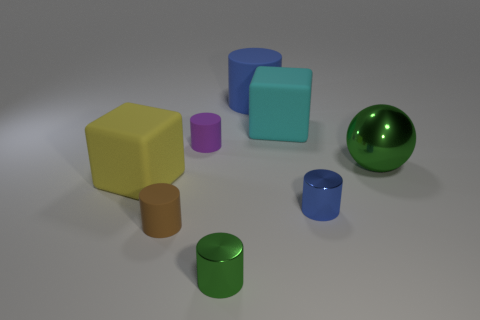Subtract all big blue cylinders. How many cylinders are left? 4 Subtract all green cylinders. How many cylinders are left? 4 Add 2 large green things. How many objects exist? 10 Subtract all spheres. How many objects are left? 7 Subtract all cyan balls. How many blue cylinders are left? 2 Subtract all small brown matte balls. Subtract all blue matte things. How many objects are left? 7 Add 3 blue rubber things. How many blue rubber things are left? 4 Add 1 balls. How many balls exist? 2 Subtract 0 blue spheres. How many objects are left? 8 Subtract all yellow cylinders. Subtract all yellow spheres. How many cylinders are left? 5 